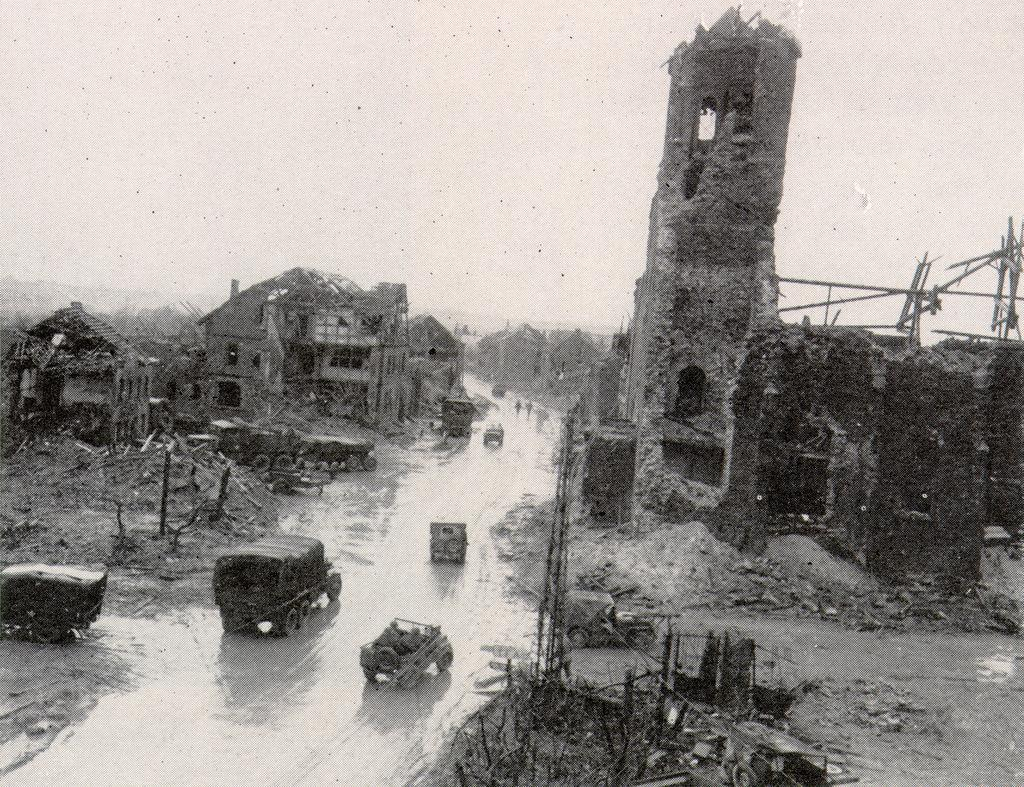What can be seen on the road in the image? There are vehicles on the road in the image. What is the condition of the buildings beside the road? The buildings beside the road appear to be destroyed. How many mice can be seen running around in the image? There are no mice present in the image. What type of seed is being planted in the image? There is no seed being planted in the image; it features vehicles on the road and destroyed buildings. 